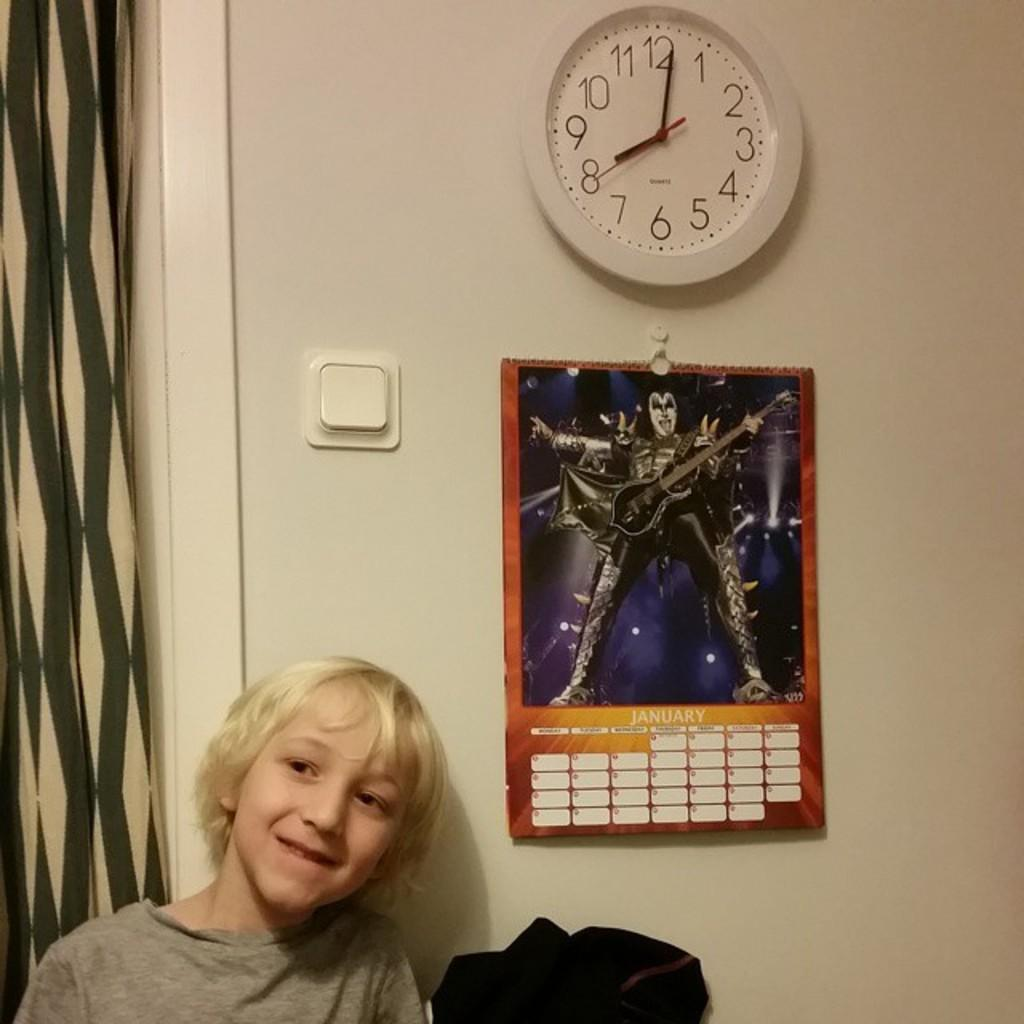<image>
Offer a succinct explanation of the picture presented. A clock on the wall shows that the time is just a bit after 8:00. 